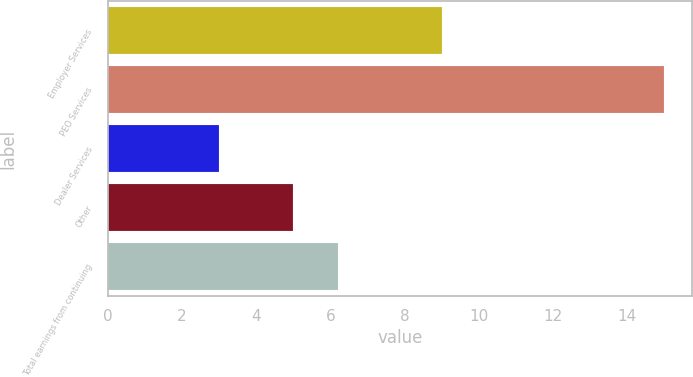Convert chart to OTSL. <chart><loc_0><loc_0><loc_500><loc_500><bar_chart><fcel>Employer Services<fcel>PEO Services<fcel>Dealer Services<fcel>Other<fcel>Total earnings from continuing<nl><fcel>9<fcel>15<fcel>3<fcel>5<fcel>6.2<nl></chart> 